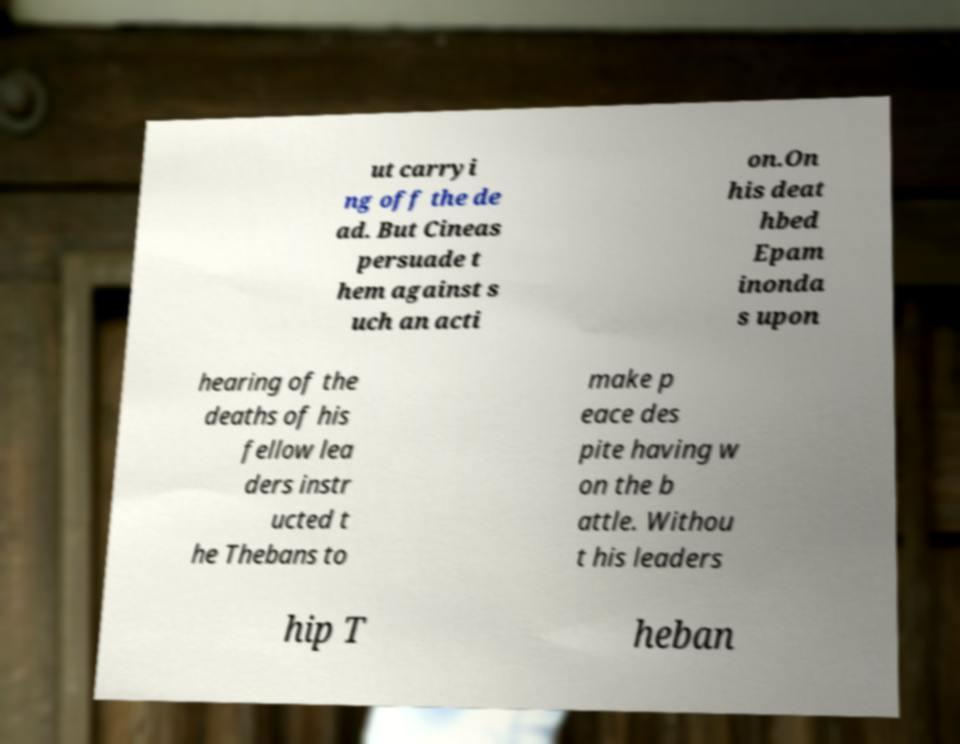What messages or text are displayed in this image? I need them in a readable, typed format. ut carryi ng off the de ad. But Cineas persuade t hem against s uch an acti on.On his deat hbed Epam inonda s upon hearing of the deaths of his fellow lea ders instr ucted t he Thebans to make p eace des pite having w on the b attle. Withou t his leaders hip T heban 